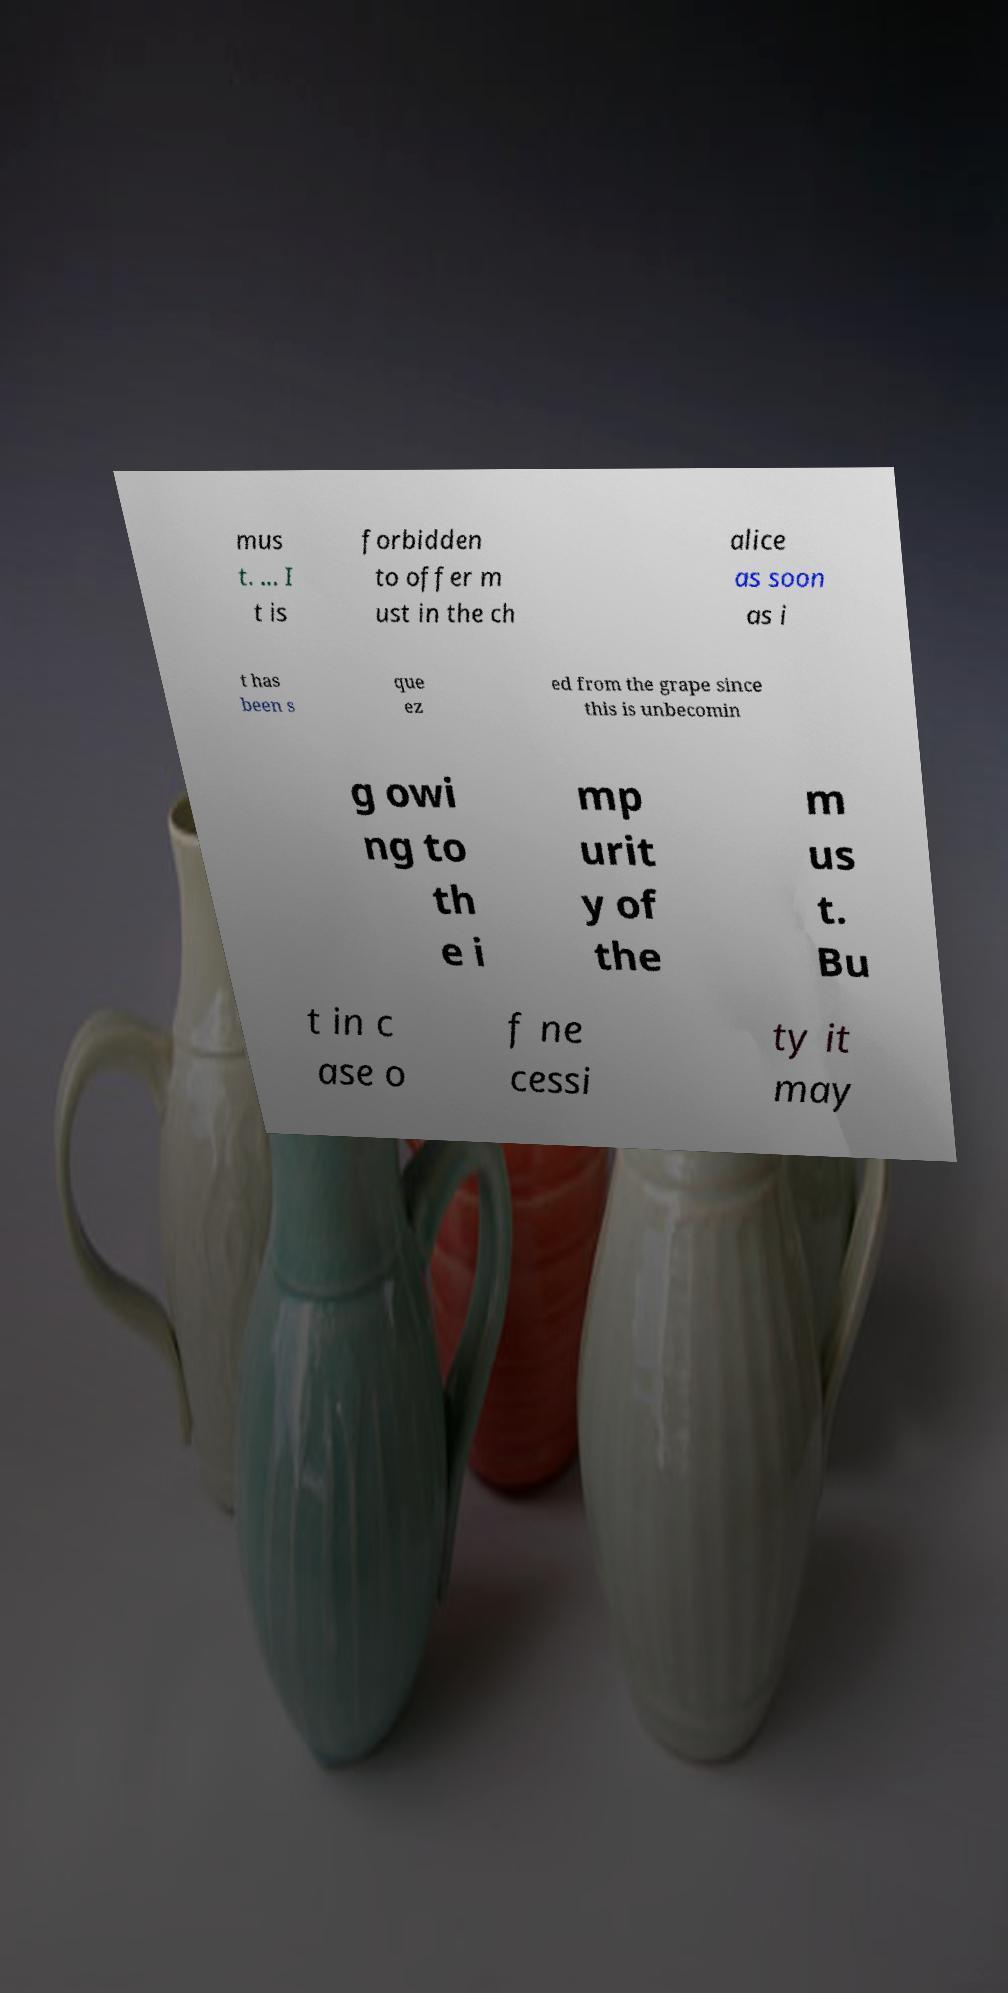Can you read and provide the text displayed in the image?This photo seems to have some interesting text. Can you extract and type it out for me? mus t. ... I t is forbidden to offer m ust in the ch alice as soon as i t has been s que ez ed from the grape since this is unbecomin g owi ng to th e i mp urit y of the m us t. Bu t in c ase o f ne cessi ty it may 